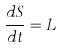Convert formula to latex. <formula><loc_0><loc_0><loc_500><loc_500>\frac { d S } { d t } = L</formula> 